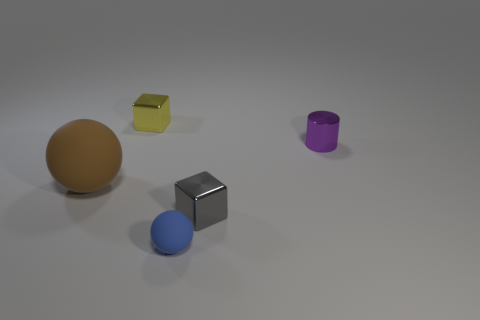Does the cube behind the small purple thing have the same material as the purple object?
Your answer should be very brief. Yes. Is the tiny yellow metallic thing the same shape as the tiny gray metallic thing?
Offer a terse response. Yes. The yellow thing that is behind the cube that is in front of the tiny cube that is behind the tiny gray object is what shape?
Offer a very short reply. Cube. Does the small metallic object that is in front of the big brown rubber object have the same shape as the rubber thing that is to the right of the yellow metal object?
Your answer should be very brief. No. Are there any big yellow balls made of the same material as the small blue thing?
Give a very brief answer. No. There is a metal cube that is behind the rubber sphere left of the metal cube that is behind the gray shiny object; what is its color?
Your response must be concise. Yellow. Is the material of the block that is behind the brown object the same as the block in front of the purple object?
Give a very brief answer. Yes. What shape is the matte thing right of the brown matte thing?
Your answer should be compact. Sphere. What number of things are either small metallic objects or purple objects behind the tiny blue sphere?
Ensure brevity in your answer.  3. Does the small yellow object have the same material as the brown sphere?
Your response must be concise. No. 